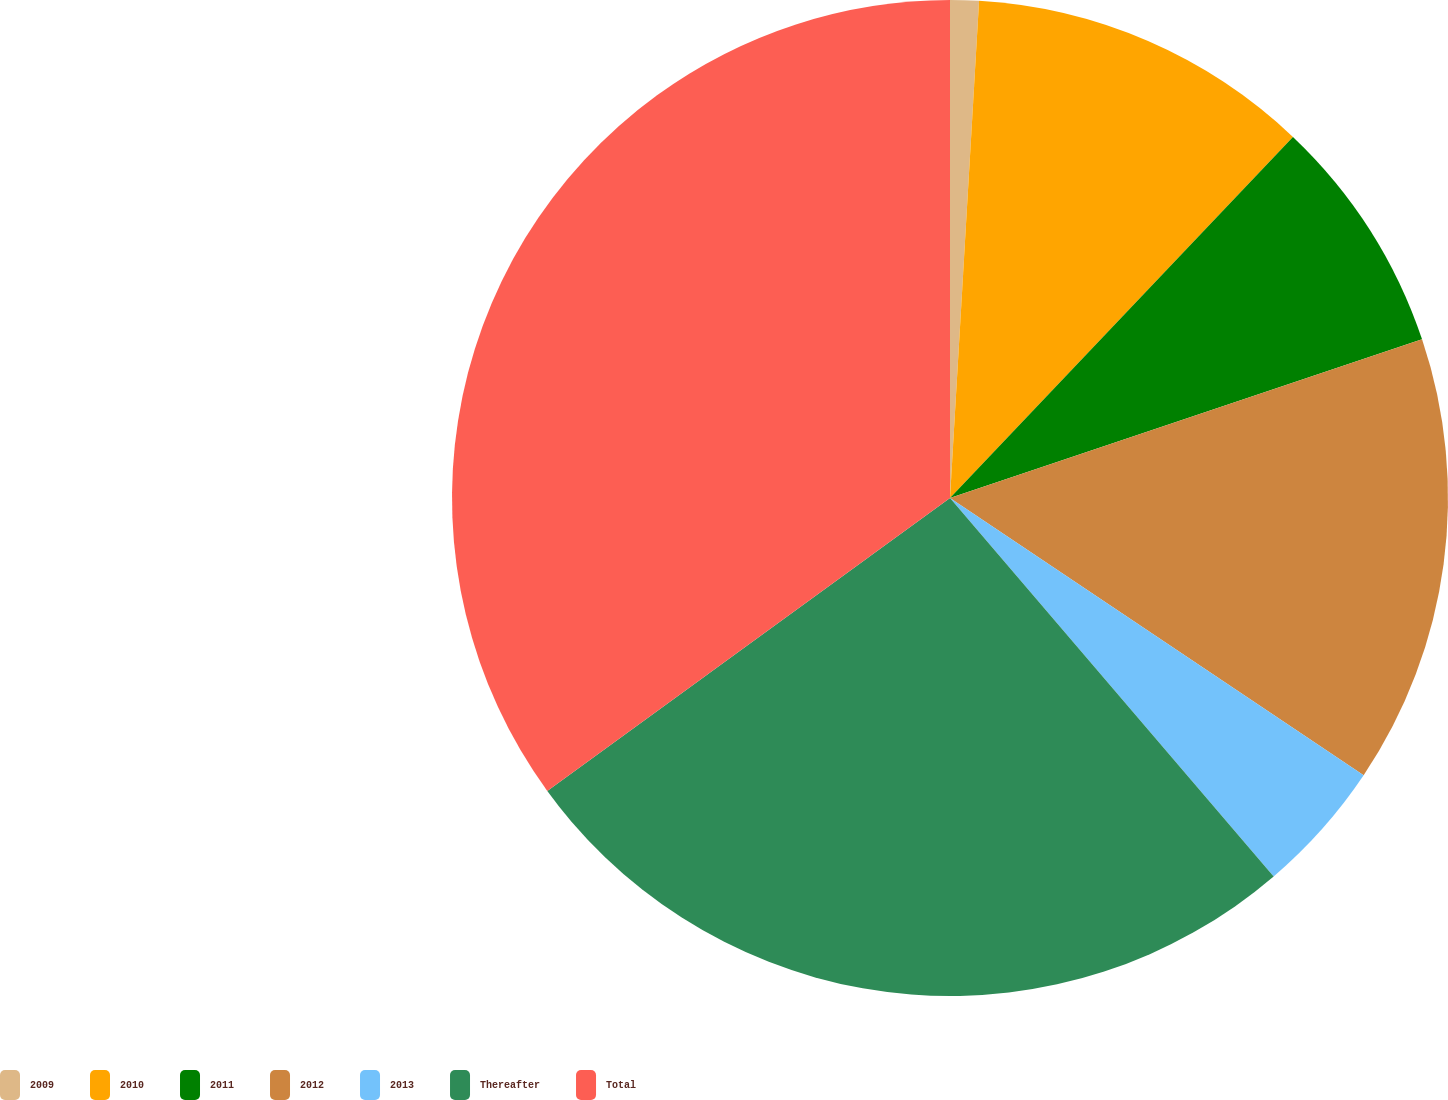Convert chart. <chart><loc_0><loc_0><loc_500><loc_500><pie_chart><fcel>2009<fcel>2010<fcel>2011<fcel>2012<fcel>2013<fcel>Thereafter<fcel>Total<nl><fcel>0.93%<fcel>11.16%<fcel>7.75%<fcel>14.56%<fcel>4.34%<fcel>26.25%<fcel>35.01%<nl></chart> 